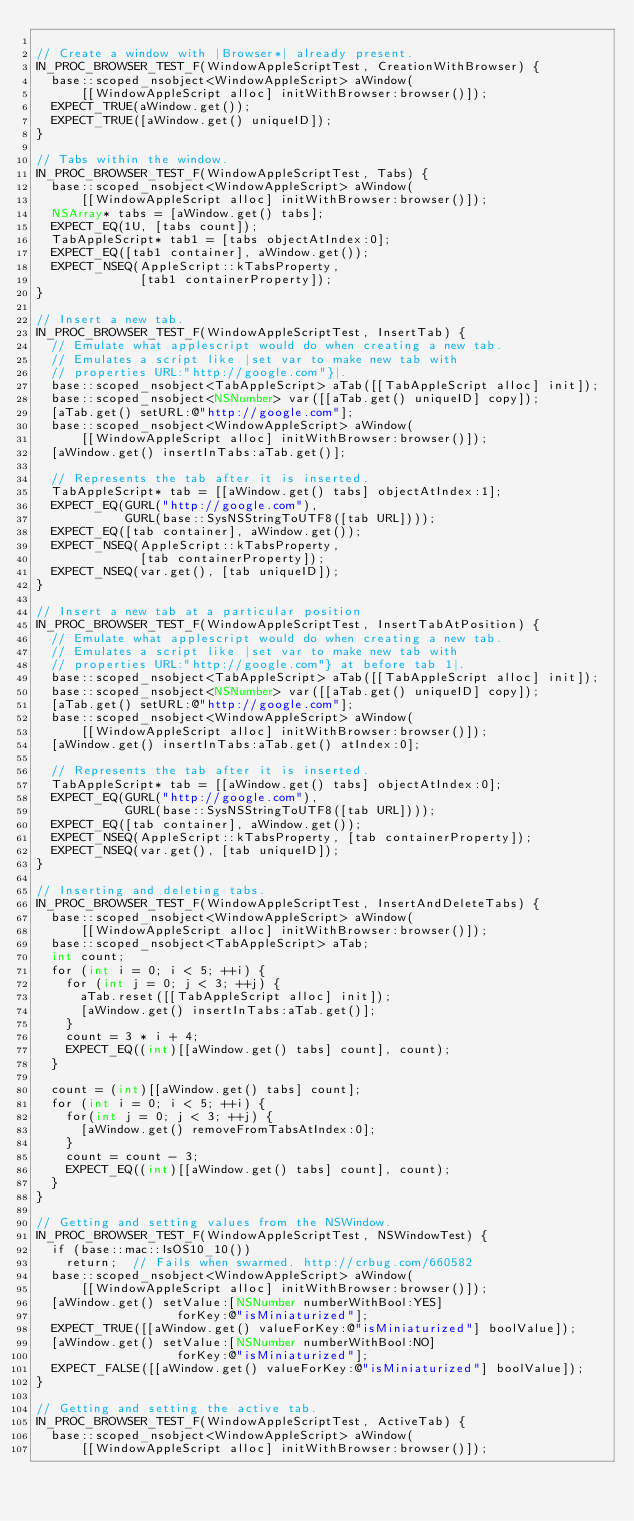<code> <loc_0><loc_0><loc_500><loc_500><_ObjectiveC_>
// Create a window with |Browser*| already present.
IN_PROC_BROWSER_TEST_F(WindowAppleScriptTest, CreationWithBrowser) {
  base::scoped_nsobject<WindowAppleScript> aWindow(
      [[WindowAppleScript alloc] initWithBrowser:browser()]);
  EXPECT_TRUE(aWindow.get());
  EXPECT_TRUE([aWindow.get() uniqueID]);
}

// Tabs within the window.
IN_PROC_BROWSER_TEST_F(WindowAppleScriptTest, Tabs) {
  base::scoped_nsobject<WindowAppleScript> aWindow(
      [[WindowAppleScript alloc] initWithBrowser:browser()]);
  NSArray* tabs = [aWindow.get() tabs];
  EXPECT_EQ(1U, [tabs count]);
  TabAppleScript* tab1 = [tabs objectAtIndex:0];
  EXPECT_EQ([tab1 container], aWindow.get());
  EXPECT_NSEQ(AppleScript::kTabsProperty,
              [tab1 containerProperty]);
}

// Insert a new tab.
IN_PROC_BROWSER_TEST_F(WindowAppleScriptTest, InsertTab) {
  // Emulate what applescript would do when creating a new tab.
  // Emulates a script like |set var to make new tab with
  // properties URL:"http://google.com"}|.
  base::scoped_nsobject<TabAppleScript> aTab([[TabAppleScript alloc] init]);
  base::scoped_nsobject<NSNumber> var([[aTab.get() uniqueID] copy]);
  [aTab.get() setURL:@"http://google.com"];
  base::scoped_nsobject<WindowAppleScript> aWindow(
      [[WindowAppleScript alloc] initWithBrowser:browser()]);
  [aWindow.get() insertInTabs:aTab.get()];

  // Represents the tab after it is inserted.
  TabAppleScript* tab = [[aWindow.get() tabs] objectAtIndex:1];
  EXPECT_EQ(GURL("http://google.com"),
            GURL(base::SysNSStringToUTF8([tab URL])));
  EXPECT_EQ([tab container], aWindow.get());
  EXPECT_NSEQ(AppleScript::kTabsProperty,
              [tab containerProperty]);
  EXPECT_NSEQ(var.get(), [tab uniqueID]);
}

// Insert a new tab at a particular position
IN_PROC_BROWSER_TEST_F(WindowAppleScriptTest, InsertTabAtPosition) {
  // Emulate what applescript would do when creating a new tab.
  // Emulates a script like |set var to make new tab with
  // properties URL:"http://google.com"} at before tab 1|.
  base::scoped_nsobject<TabAppleScript> aTab([[TabAppleScript alloc] init]);
  base::scoped_nsobject<NSNumber> var([[aTab.get() uniqueID] copy]);
  [aTab.get() setURL:@"http://google.com"];
  base::scoped_nsobject<WindowAppleScript> aWindow(
      [[WindowAppleScript alloc] initWithBrowser:browser()]);
  [aWindow.get() insertInTabs:aTab.get() atIndex:0];

  // Represents the tab after it is inserted.
  TabAppleScript* tab = [[aWindow.get() tabs] objectAtIndex:0];
  EXPECT_EQ(GURL("http://google.com"),
            GURL(base::SysNSStringToUTF8([tab URL])));
  EXPECT_EQ([tab container], aWindow.get());
  EXPECT_NSEQ(AppleScript::kTabsProperty, [tab containerProperty]);
  EXPECT_NSEQ(var.get(), [tab uniqueID]);
}

// Inserting and deleting tabs.
IN_PROC_BROWSER_TEST_F(WindowAppleScriptTest, InsertAndDeleteTabs) {
  base::scoped_nsobject<WindowAppleScript> aWindow(
      [[WindowAppleScript alloc] initWithBrowser:browser()]);
  base::scoped_nsobject<TabAppleScript> aTab;
  int count;
  for (int i = 0; i < 5; ++i) {
    for (int j = 0; j < 3; ++j) {
      aTab.reset([[TabAppleScript alloc] init]);
      [aWindow.get() insertInTabs:aTab.get()];
    }
    count = 3 * i + 4;
    EXPECT_EQ((int)[[aWindow.get() tabs] count], count);
  }

  count = (int)[[aWindow.get() tabs] count];
  for (int i = 0; i < 5; ++i) {
    for(int j = 0; j < 3; ++j) {
      [aWindow.get() removeFromTabsAtIndex:0];
    }
    count = count - 3;
    EXPECT_EQ((int)[[aWindow.get() tabs] count], count);
  }
}

// Getting and setting values from the NSWindow.
IN_PROC_BROWSER_TEST_F(WindowAppleScriptTest, NSWindowTest) {
  if (base::mac::IsOS10_10())
    return;  // Fails when swarmed. http://crbug.com/660582
  base::scoped_nsobject<WindowAppleScript> aWindow(
      [[WindowAppleScript alloc] initWithBrowser:browser()]);
  [aWindow.get() setValue:[NSNumber numberWithBool:YES]
                   forKey:@"isMiniaturized"];
  EXPECT_TRUE([[aWindow.get() valueForKey:@"isMiniaturized"] boolValue]);
  [aWindow.get() setValue:[NSNumber numberWithBool:NO]
                   forKey:@"isMiniaturized"];
  EXPECT_FALSE([[aWindow.get() valueForKey:@"isMiniaturized"] boolValue]);
}

// Getting and setting the active tab.
IN_PROC_BROWSER_TEST_F(WindowAppleScriptTest, ActiveTab) {
  base::scoped_nsobject<WindowAppleScript> aWindow(
      [[WindowAppleScript alloc] initWithBrowser:browser()]);</code> 